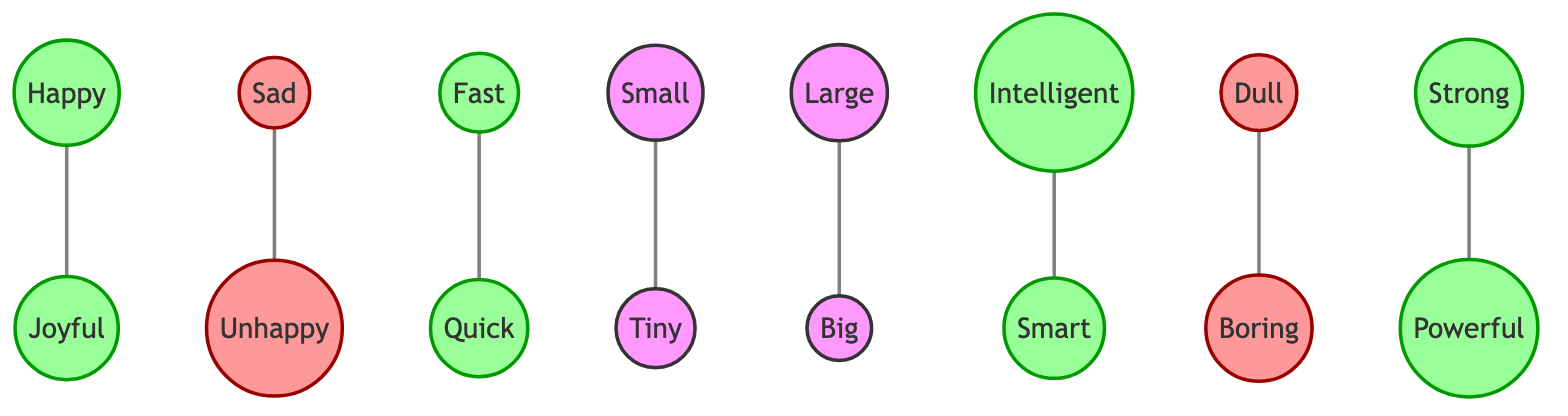What is the total number of nodes in the graph? To find the total number of nodes, we count all the unique nodes listed in the data under "nodes". There are 15 nodes: Happy, Joyful, Sad, Unhappy, Fast, Quick, Small, Tiny, Large, Big, Intelligent, Smart, Dull, Boring, Strong, and Powerful.
Answer: 15 Which words are synonyms for "happy"? By looking at the edges, we can see that "happy" is connected to "joyful", indicating they are synonyms.
Answer: Joyful What is the relationship between "sad" and "unhappy"? In the graph, there is an edge connecting "sad" to "unhappy", which shows that they are related as synonyms.
Answer: Synonyms How many edges are present in the graph? We look at the "edges" section of the data to find the total number of connections. There are 7 edges represented in the graph.
Answer: 7 Which pairs share a positive sentiment in the graph? The positive nodes identified in the graph include Happy, Joyful, Fast, Quick, Intelligent, Smart, Strong, and Powerful. This information can be summarized as pairs: (Happy, Joyful), (Fast, Quick), (Intelligent, Smart), and (Strong, Powerful).
Answer: Happy, Joyful; Fast, Quick; Intelligent, Smart; Strong, Powerful What is a synonym for "big"? The graph indicates "big" is synonymous with "large", as they are connected by an edge.
Answer: Large Which synonym connects to "dull"? According to the edges in the graph, "dull" is connected to "boring", indicating they are synonyms.
Answer: Boring How many negative sentiment words are in the graph? By reviewing the nodes, we identify which words have a negative connotation: Sad, Unhappy, Dull, and Boring, which totals to 4 negative words.
Answer: 4 What are the two words that both mean "fast"? The graph shows a connection between "fast" and "quick", meaning these two words are synonyms for "fast".
Answer: Quick 